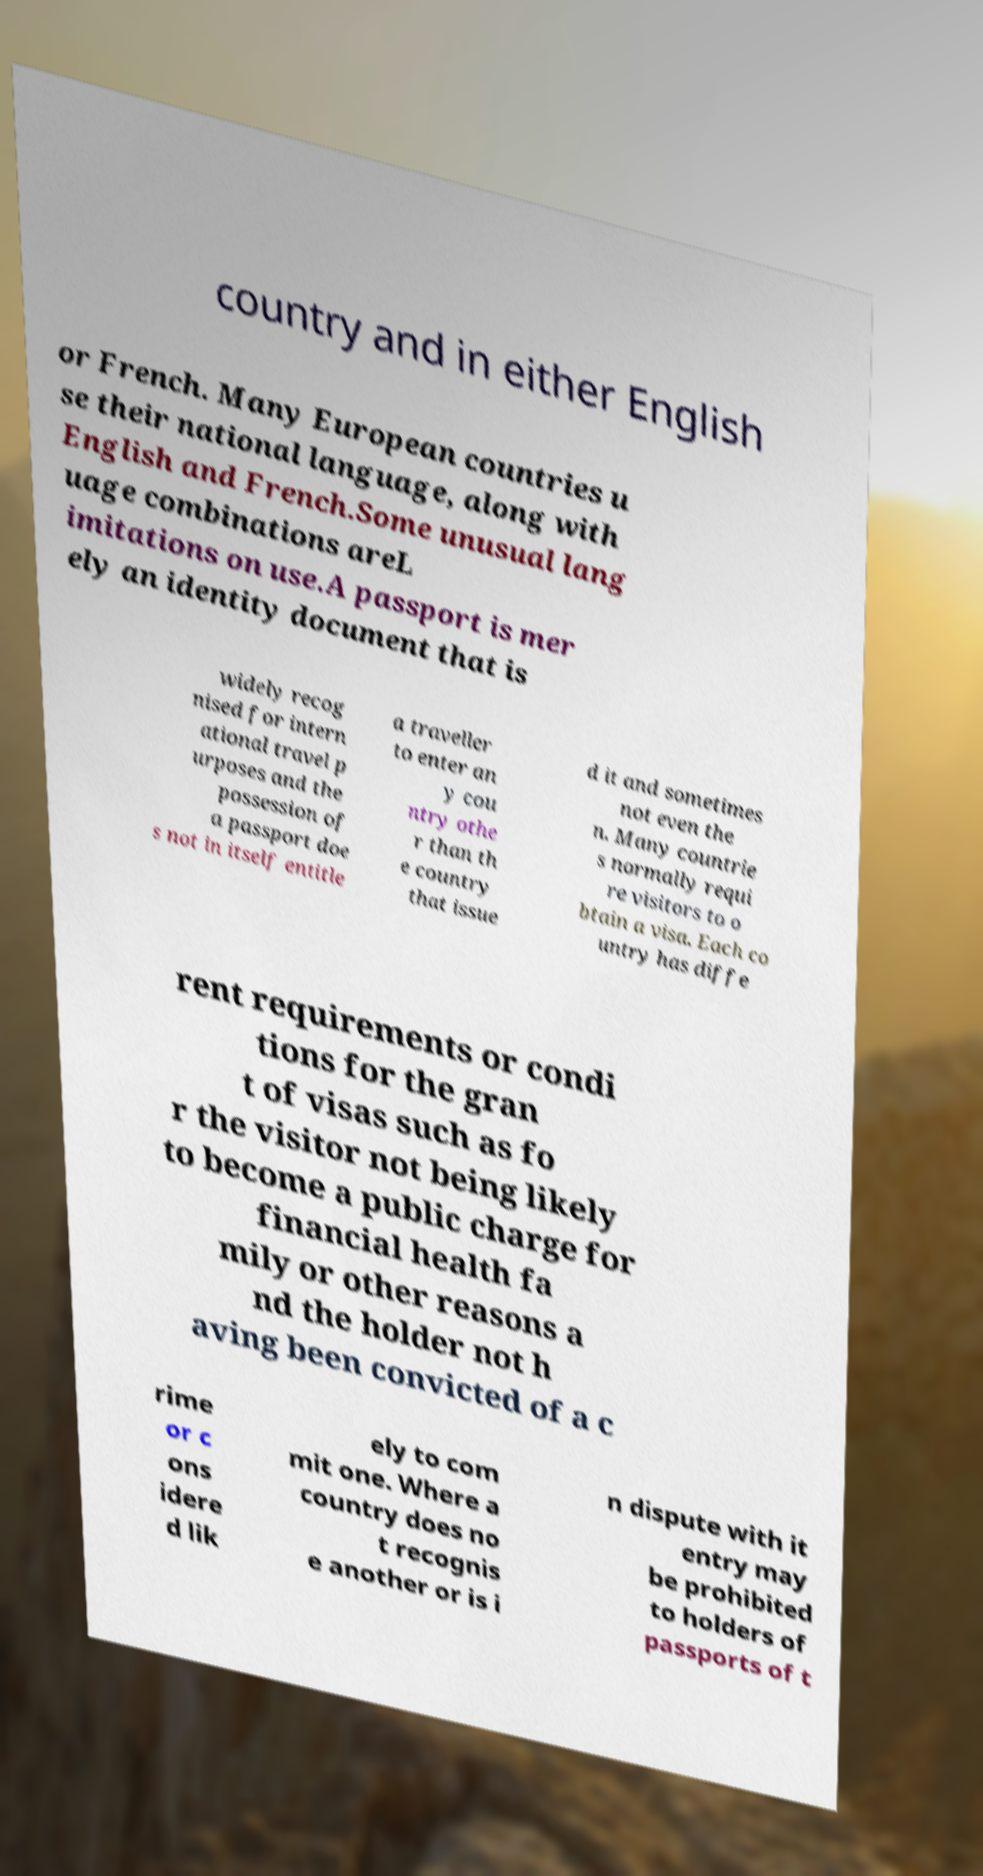Can you read and provide the text displayed in the image?This photo seems to have some interesting text. Can you extract and type it out for me? country and in either English or French. Many European countries u se their national language, along with English and French.Some unusual lang uage combinations areL imitations on use.A passport is mer ely an identity document that is widely recog nised for intern ational travel p urposes and the possession of a passport doe s not in itself entitle a traveller to enter an y cou ntry othe r than th e country that issue d it and sometimes not even the n. Many countrie s normally requi re visitors to o btain a visa. Each co untry has diffe rent requirements or condi tions for the gran t of visas such as fo r the visitor not being likely to become a public charge for financial health fa mily or other reasons a nd the holder not h aving been convicted of a c rime or c ons idere d lik ely to com mit one. Where a country does no t recognis e another or is i n dispute with it entry may be prohibited to holders of passports of t 